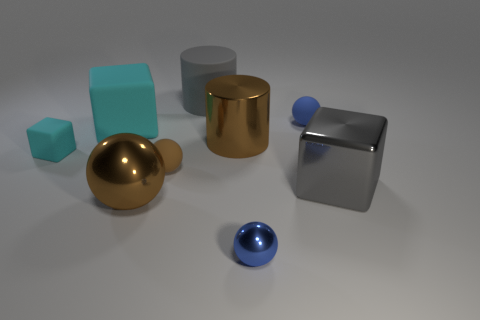Subtract all cylinders. How many objects are left? 7 Subtract 0 green cylinders. How many objects are left? 9 Subtract all small yellow rubber cylinders. Subtract all brown shiny spheres. How many objects are left? 8 Add 4 big brown cylinders. How many big brown cylinders are left? 5 Add 2 tiny cyan rubber cubes. How many tiny cyan rubber cubes exist? 3 